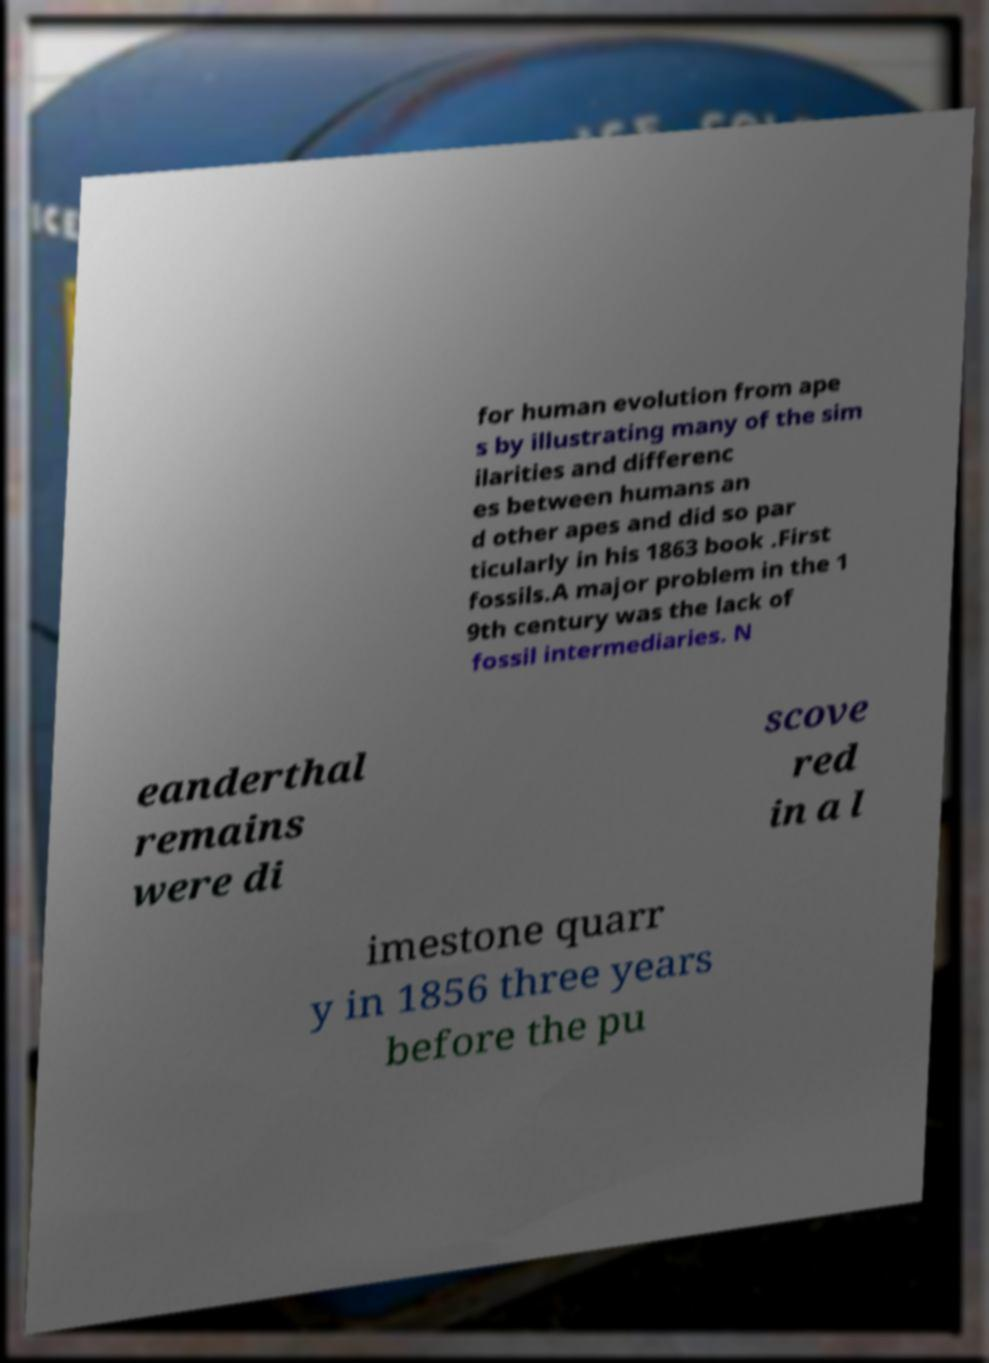Could you assist in decoding the text presented in this image and type it out clearly? for human evolution from ape s by illustrating many of the sim ilarities and differenc es between humans an d other apes and did so par ticularly in his 1863 book .First fossils.A major problem in the 1 9th century was the lack of fossil intermediaries. N eanderthal remains were di scove red in a l imestone quarr y in 1856 three years before the pu 